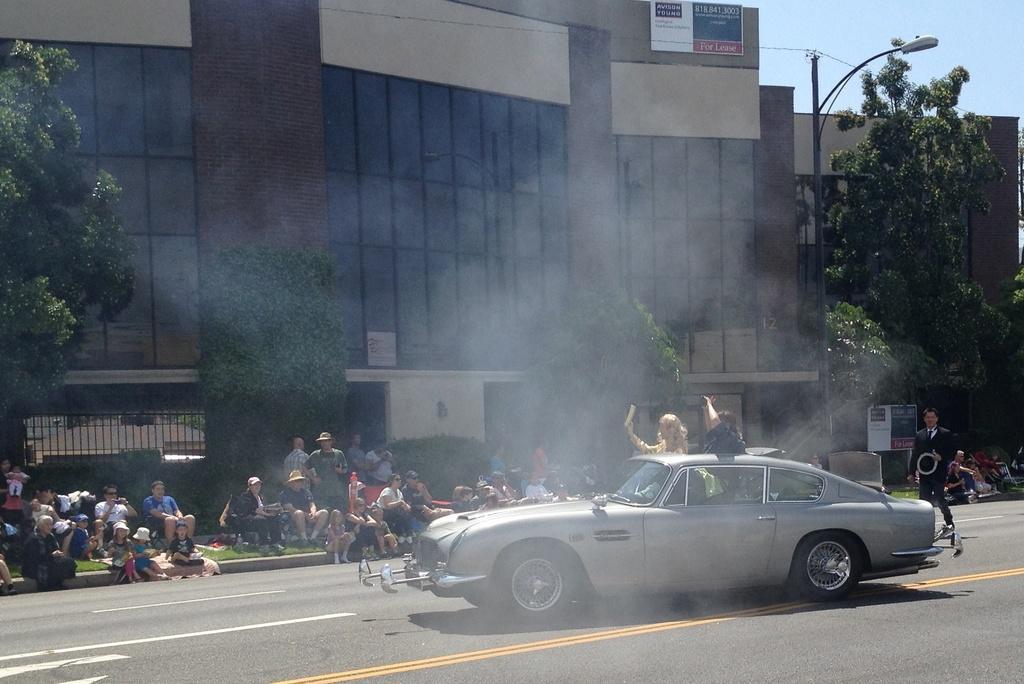How would you summarize this image in a sentence or two? In this image we can see a building, there are trees, there are group of people sitting on a grass, there is a car travelling on a road, there are group of people standing, there is a street light, there is a sky. 